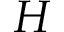<formula> <loc_0><loc_0><loc_500><loc_500>H</formula> 